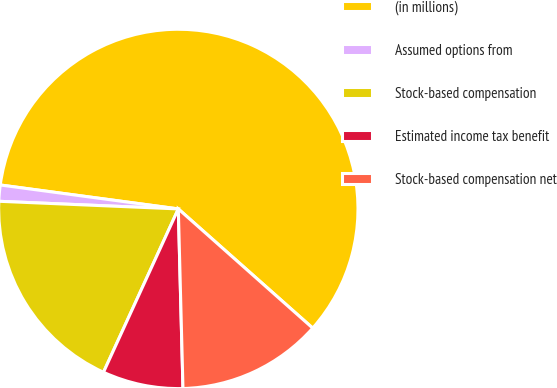Convert chart to OTSL. <chart><loc_0><loc_0><loc_500><loc_500><pie_chart><fcel>(in millions)<fcel>Assumed options from<fcel>Stock-based compensation<fcel>Estimated income tax benefit<fcel>Stock-based compensation net<nl><fcel>59.42%<fcel>1.45%<fcel>18.84%<fcel>7.25%<fcel>13.04%<nl></chart> 